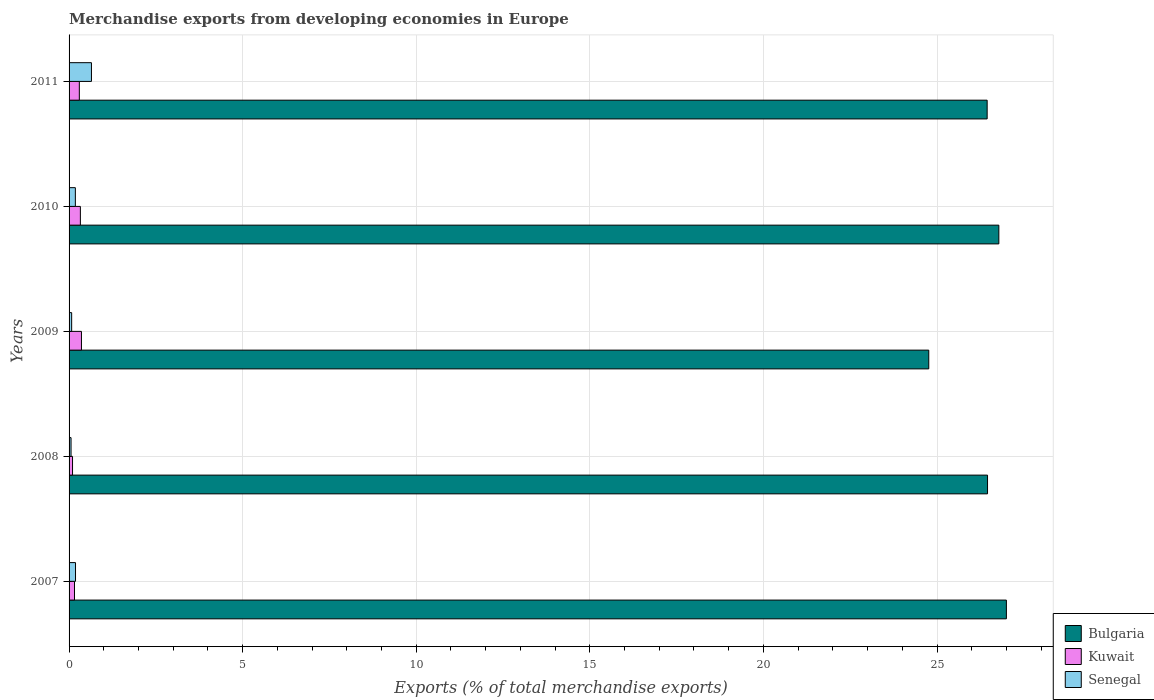How many different coloured bars are there?
Offer a terse response. 3. How many groups of bars are there?
Ensure brevity in your answer.  5. What is the label of the 2nd group of bars from the top?
Your response must be concise. 2010. In how many cases, is the number of bars for a given year not equal to the number of legend labels?
Give a very brief answer. 0. What is the percentage of total merchandise exports in Kuwait in 2008?
Your response must be concise. 0.1. Across all years, what is the maximum percentage of total merchandise exports in Senegal?
Offer a terse response. 0.64. Across all years, what is the minimum percentage of total merchandise exports in Kuwait?
Make the answer very short. 0.1. In which year was the percentage of total merchandise exports in Senegal maximum?
Your response must be concise. 2011. What is the total percentage of total merchandise exports in Bulgaria in the graph?
Provide a succinct answer. 131.44. What is the difference between the percentage of total merchandise exports in Senegal in 2008 and that in 2010?
Give a very brief answer. -0.12. What is the difference between the percentage of total merchandise exports in Senegal in 2010 and the percentage of total merchandise exports in Bulgaria in 2011?
Provide a short and direct response. -26.26. What is the average percentage of total merchandise exports in Bulgaria per year?
Your answer should be compact. 26.29. In the year 2007, what is the difference between the percentage of total merchandise exports in Bulgaria and percentage of total merchandise exports in Kuwait?
Offer a terse response. 26.84. In how many years, is the percentage of total merchandise exports in Bulgaria greater than 2 %?
Your answer should be compact. 5. What is the ratio of the percentage of total merchandise exports in Bulgaria in 2008 to that in 2009?
Your answer should be very brief. 1.07. What is the difference between the highest and the second highest percentage of total merchandise exports in Kuwait?
Provide a short and direct response. 0.03. What is the difference between the highest and the lowest percentage of total merchandise exports in Senegal?
Offer a terse response. 0.59. In how many years, is the percentage of total merchandise exports in Senegal greater than the average percentage of total merchandise exports in Senegal taken over all years?
Provide a short and direct response. 1. Is the sum of the percentage of total merchandise exports in Bulgaria in 2008 and 2011 greater than the maximum percentage of total merchandise exports in Kuwait across all years?
Make the answer very short. Yes. What does the 3rd bar from the top in 2010 represents?
Your answer should be very brief. Bulgaria. What does the 2nd bar from the bottom in 2008 represents?
Keep it short and to the point. Kuwait. Is it the case that in every year, the sum of the percentage of total merchandise exports in Bulgaria and percentage of total merchandise exports in Senegal is greater than the percentage of total merchandise exports in Kuwait?
Provide a succinct answer. Yes. Are all the bars in the graph horizontal?
Provide a short and direct response. Yes. How many years are there in the graph?
Provide a succinct answer. 5. Are the values on the major ticks of X-axis written in scientific E-notation?
Provide a succinct answer. No. Where does the legend appear in the graph?
Provide a short and direct response. Bottom right. How many legend labels are there?
Offer a very short reply. 3. How are the legend labels stacked?
Ensure brevity in your answer.  Vertical. What is the title of the graph?
Your response must be concise. Merchandise exports from developing economies in Europe. What is the label or title of the X-axis?
Your answer should be compact. Exports (% of total merchandise exports). What is the label or title of the Y-axis?
Offer a very short reply. Years. What is the Exports (% of total merchandise exports) of Bulgaria in 2007?
Provide a succinct answer. 27. What is the Exports (% of total merchandise exports) of Kuwait in 2007?
Make the answer very short. 0.16. What is the Exports (% of total merchandise exports) in Senegal in 2007?
Your response must be concise. 0.19. What is the Exports (% of total merchandise exports) in Bulgaria in 2008?
Your answer should be compact. 26.46. What is the Exports (% of total merchandise exports) in Kuwait in 2008?
Make the answer very short. 0.1. What is the Exports (% of total merchandise exports) in Senegal in 2008?
Offer a terse response. 0.06. What is the Exports (% of total merchandise exports) of Bulgaria in 2009?
Provide a short and direct response. 24.76. What is the Exports (% of total merchandise exports) of Kuwait in 2009?
Your response must be concise. 0.36. What is the Exports (% of total merchandise exports) in Senegal in 2009?
Provide a short and direct response. 0.07. What is the Exports (% of total merchandise exports) of Bulgaria in 2010?
Provide a short and direct response. 26.78. What is the Exports (% of total merchandise exports) of Kuwait in 2010?
Make the answer very short. 0.33. What is the Exports (% of total merchandise exports) in Senegal in 2010?
Keep it short and to the point. 0.18. What is the Exports (% of total merchandise exports) in Bulgaria in 2011?
Provide a succinct answer. 26.44. What is the Exports (% of total merchandise exports) in Kuwait in 2011?
Ensure brevity in your answer.  0.3. What is the Exports (% of total merchandise exports) of Senegal in 2011?
Provide a succinct answer. 0.64. Across all years, what is the maximum Exports (% of total merchandise exports) in Bulgaria?
Your response must be concise. 27. Across all years, what is the maximum Exports (% of total merchandise exports) of Kuwait?
Give a very brief answer. 0.36. Across all years, what is the maximum Exports (% of total merchandise exports) in Senegal?
Your response must be concise. 0.64. Across all years, what is the minimum Exports (% of total merchandise exports) of Bulgaria?
Provide a short and direct response. 24.76. Across all years, what is the minimum Exports (% of total merchandise exports) of Kuwait?
Your answer should be very brief. 0.1. Across all years, what is the minimum Exports (% of total merchandise exports) in Senegal?
Offer a very short reply. 0.06. What is the total Exports (% of total merchandise exports) in Bulgaria in the graph?
Offer a terse response. 131.44. What is the total Exports (% of total merchandise exports) in Kuwait in the graph?
Your answer should be very brief. 1.23. What is the total Exports (% of total merchandise exports) in Senegal in the graph?
Give a very brief answer. 1.14. What is the difference between the Exports (% of total merchandise exports) of Bulgaria in 2007 and that in 2008?
Keep it short and to the point. 0.54. What is the difference between the Exports (% of total merchandise exports) of Kuwait in 2007 and that in 2008?
Provide a succinct answer. 0.06. What is the difference between the Exports (% of total merchandise exports) in Senegal in 2007 and that in 2008?
Keep it short and to the point. 0.13. What is the difference between the Exports (% of total merchandise exports) of Bulgaria in 2007 and that in 2009?
Ensure brevity in your answer.  2.24. What is the difference between the Exports (% of total merchandise exports) in Kuwait in 2007 and that in 2009?
Provide a succinct answer. -0.2. What is the difference between the Exports (% of total merchandise exports) of Senegal in 2007 and that in 2009?
Give a very brief answer. 0.11. What is the difference between the Exports (% of total merchandise exports) of Bulgaria in 2007 and that in 2010?
Keep it short and to the point. 0.22. What is the difference between the Exports (% of total merchandise exports) of Kuwait in 2007 and that in 2010?
Your answer should be very brief. -0.17. What is the difference between the Exports (% of total merchandise exports) of Senegal in 2007 and that in 2010?
Make the answer very short. 0. What is the difference between the Exports (% of total merchandise exports) of Bulgaria in 2007 and that in 2011?
Your answer should be very brief. 0.55. What is the difference between the Exports (% of total merchandise exports) in Kuwait in 2007 and that in 2011?
Provide a short and direct response. -0.14. What is the difference between the Exports (% of total merchandise exports) in Senegal in 2007 and that in 2011?
Give a very brief answer. -0.46. What is the difference between the Exports (% of total merchandise exports) in Bulgaria in 2008 and that in 2009?
Offer a very short reply. 1.69. What is the difference between the Exports (% of total merchandise exports) of Kuwait in 2008 and that in 2009?
Your answer should be compact. -0.26. What is the difference between the Exports (% of total merchandise exports) in Senegal in 2008 and that in 2009?
Offer a terse response. -0.02. What is the difference between the Exports (% of total merchandise exports) in Bulgaria in 2008 and that in 2010?
Your response must be concise. -0.33. What is the difference between the Exports (% of total merchandise exports) in Kuwait in 2008 and that in 2010?
Provide a short and direct response. -0.23. What is the difference between the Exports (% of total merchandise exports) of Senegal in 2008 and that in 2010?
Your answer should be compact. -0.12. What is the difference between the Exports (% of total merchandise exports) of Bulgaria in 2008 and that in 2011?
Your answer should be very brief. 0.01. What is the difference between the Exports (% of total merchandise exports) in Kuwait in 2008 and that in 2011?
Give a very brief answer. -0.2. What is the difference between the Exports (% of total merchandise exports) in Senegal in 2008 and that in 2011?
Offer a terse response. -0.59. What is the difference between the Exports (% of total merchandise exports) of Bulgaria in 2009 and that in 2010?
Offer a terse response. -2.02. What is the difference between the Exports (% of total merchandise exports) in Kuwait in 2009 and that in 2010?
Provide a succinct answer. 0.03. What is the difference between the Exports (% of total merchandise exports) in Senegal in 2009 and that in 2010?
Make the answer very short. -0.11. What is the difference between the Exports (% of total merchandise exports) in Bulgaria in 2009 and that in 2011?
Provide a short and direct response. -1.68. What is the difference between the Exports (% of total merchandise exports) in Kuwait in 2009 and that in 2011?
Your response must be concise. 0.06. What is the difference between the Exports (% of total merchandise exports) of Senegal in 2009 and that in 2011?
Offer a terse response. -0.57. What is the difference between the Exports (% of total merchandise exports) of Bulgaria in 2010 and that in 2011?
Keep it short and to the point. 0.34. What is the difference between the Exports (% of total merchandise exports) of Kuwait in 2010 and that in 2011?
Provide a short and direct response. 0.03. What is the difference between the Exports (% of total merchandise exports) in Senegal in 2010 and that in 2011?
Provide a short and direct response. -0.46. What is the difference between the Exports (% of total merchandise exports) of Bulgaria in 2007 and the Exports (% of total merchandise exports) of Kuwait in 2008?
Your answer should be very brief. 26.9. What is the difference between the Exports (% of total merchandise exports) in Bulgaria in 2007 and the Exports (% of total merchandise exports) in Senegal in 2008?
Your answer should be compact. 26.94. What is the difference between the Exports (% of total merchandise exports) in Kuwait in 2007 and the Exports (% of total merchandise exports) in Senegal in 2008?
Make the answer very short. 0.1. What is the difference between the Exports (% of total merchandise exports) of Bulgaria in 2007 and the Exports (% of total merchandise exports) of Kuwait in 2009?
Give a very brief answer. 26.64. What is the difference between the Exports (% of total merchandise exports) in Bulgaria in 2007 and the Exports (% of total merchandise exports) in Senegal in 2009?
Offer a terse response. 26.92. What is the difference between the Exports (% of total merchandise exports) in Kuwait in 2007 and the Exports (% of total merchandise exports) in Senegal in 2009?
Your answer should be compact. 0.08. What is the difference between the Exports (% of total merchandise exports) of Bulgaria in 2007 and the Exports (% of total merchandise exports) of Kuwait in 2010?
Your answer should be very brief. 26.67. What is the difference between the Exports (% of total merchandise exports) of Bulgaria in 2007 and the Exports (% of total merchandise exports) of Senegal in 2010?
Keep it short and to the point. 26.82. What is the difference between the Exports (% of total merchandise exports) of Kuwait in 2007 and the Exports (% of total merchandise exports) of Senegal in 2010?
Your answer should be compact. -0.02. What is the difference between the Exports (% of total merchandise exports) of Bulgaria in 2007 and the Exports (% of total merchandise exports) of Kuwait in 2011?
Keep it short and to the point. 26.7. What is the difference between the Exports (% of total merchandise exports) of Bulgaria in 2007 and the Exports (% of total merchandise exports) of Senegal in 2011?
Offer a very short reply. 26.35. What is the difference between the Exports (% of total merchandise exports) in Kuwait in 2007 and the Exports (% of total merchandise exports) in Senegal in 2011?
Offer a terse response. -0.49. What is the difference between the Exports (% of total merchandise exports) of Bulgaria in 2008 and the Exports (% of total merchandise exports) of Kuwait in 2009?
Give a very brief answer. 26.1. What is the difference between the Exports (% of total merchandise exports) of Bulgaria in 2008 and the Exports (% of total merchandise exports) of Senegal in 2009?
Your answer should be very brief. 26.38. What is the difference between the Exports (% of total merchandise exports) of Kuwait in 2008 and the Exports (% of total merchandise exports) of Senegal in 2009?
Provide a succinct answer. 0.03. What is the difference between the Exports (% of total merchandise exports) in Bulgaria in 2008 and the Exports (% of total merchandise exports) in Kuwait in 2010?
Your answer should be very brief. 26.13. What is the difference between the Exports (% of total merchandise exports) in Bulgaria in 2008 and the Exports (% of total merchandise exports) in Senegal in 2010?
Offer a terse response. 26.27. What is the difference between the Exports (% of total merchandise exports) in Kuwait in 2008 and the Exports (% of total merchandise exports) in Senegal in 2010?
Offer a very short reply. -0.08. What is the difference between the Exports (% of total merchandise exports) in Bulgaria in 2008 and the Exports (% of total merchandise exports) in Kuwait in 2011?
Your answer should be very brief. 26.16. What is the difference between the Exports (% of total merchandise exports) of Bulgaria in 2008 and the Exports (% of total merchandise exports) of Senegal in 2011?
Provide a short and direct response. 25.81. What is the difference between the Exports (% of total merchandise exports) of Kuwait in 2008 and the Exports (% of total merchandise exports) of Senegal in 2011?
Provide a succinct answer. -0.55. What is the difference between the Exports (% of total merchandise exports) in Bulgaria in 2009 and the Exports (% of total merchandise exports) in Kuwait in 2010?
Ensure brevity in your answer.  24.44. What is the difference between the Exports (% of total merchandise exports) in Bulgaria in 2009 and the Exports (% of total merchandise exports) in Senegal in 2010?
Make the answer very short. 24.58. What is the difference between the Exports (% of total merchandise exports) in Kuwait in 2009 and the Exports (% of total merchandise exports) in Senegal in 2010?
Provide a short and direct response. 0.18. What is the difference between the Exports (% of total merchandise exports) of Bulgaria in 2009 and the Exports (% of total merchandise exports) of Kuwait in 2011?
Offer a very short reply. 24.47. What is the difference between the Exports (% of total merchandise exports) of Bulgaria in 2009 and the Exports (% of total merchandise exports) of Senegal in 2011?
Offer a very short reply. 24.12. What is the difference between the Exports (% of total merchandise exports) of Kuwait in 2009 and the Exports (% of total merchandise exports) of Senegal in 2011?
Offer a terse response. -0.29. What is the difference between the Exports (% of total merchandise exports) of Bulgaria in 2010 and the Exports (% of total merchandise exports) of Kuwait in 2011?
Provide a succinct answer. 26.49. What is the difference between the Exports (% of total merchandise exports) in Bulgaria in 2010 and the Exports (% of total merchandise exports) in Senegal in 2011?
Your answer should be compact. 26.14. What is the difference between the Exports (% of total merchandise exports) of Kuwait in 2010 and the Exports (% of total merchandise exports) of Senegal in 2011?
Provide a short and direct response. -0.32. What is the average Exports (% of total merchandise exports) in Bulgaria per year?
Give a very brief answer. 26.29. What is the average Exports (% of total merchandise exports) in Kuwait per year?
Your answer should be very brief. 0.25. What is the average Exports (% of total merchandise exports) in Senegal per year?
Your response must be concise. 0.23. In the year 2007, what is the difference between the Exports (% of total merchandise exports) in Bulgaria and Exports (% of total merchandise exports) in Kuwait?
Give a very brief answer. 26.84. In the year 2007, what is the difference between the Exports (% of total merchandise exports) of Bulgaria and Exports (% of total merchandise exports) of Senegal?
Give a very brief answer. 26.81. In the year 2007, what is the difference between the Exports (% of total merchandise exports) of Kuwait and Exports (% of total merchandise exports) of Senegal?
Your response must be concise. -0.03. In the year 2008, what is the difference between the Exports (% of total merchandise exports) of Bulgaria and Exports (% of total merchandise exports) of Kuwait?
Keep it short and to the point. 26.36. In the year 2008, what is the difference between the Exports (% of total merchandise exports) in Bulgaria and Exports (% of total merchandise exports) in Senegal?
Provide a succinct answer. 26.4. In the year 2008, what is the difference between the Exports (% of total merchandise exports) of Kuwait and Exports (% of total merchandise exports) of Senegal?
Ensure brevity in your answer.  0.04. In the year 2009, what is the difference between the Exports (% of total merchandise exports) of Bulgaria and Exports (% of total merchandise exports) of Kuwait?
Provide a succinct answer. 24.41. In the year 2009, what is the difference between the Exports (% of total merchandise exports) of Bulgaria and Exports (% of total merchandise exports) of Senegal?
Your response must be concise. 24.69. In the year 2009, what is the difference between the Exports (% of total merchandise exports) of Kuwait and Exports (% of total merchandise exports) of Senegal?
Provide a short and direct response. 0.28. In the year 2010, what is the difference between the Exports (% of total merchandise exports) of Bulgaria and Exports (% of total merchandise exports) of Kuwait?
Offer a very short reply. 26.46. In the year 2010, what is the difference between the Exports (% of total merchandise exports) of Bulgaria and Exports (% of total merchandise exports) of Senegal?
Your answer should be compact. 26.6. In the year 2010, what is the difference between the Exports (% of total merchandise exports) in Kuwait and Exports (% of total merchandise exports) in Senegal?
Make the answer very short. 0.14. In the year 2011, what is the difference between the Exports (% of total merchandise exports) in Bulgaria and Exports (% of total merchandise exports) in Kuwait?
Your answer should be compact. 26.15. In the year 2011, what is the difference between the Exports (% of total merchandise exports) of Bulgaria and Exports (% of total merchandise exports) of Senegal?
Offer a terse response. 25.8. In the year 2011, what is the difference between the Exports (% of total merchandise exports) of Kuwait and Exports (% of total merchandise exports) of Senegal?
Your answer should be very brief. -0.35. What is the ratio of the Exports (% of total merchandise exports) in Bulgaria in 2007 to that in 2008?
Your response must be concise. 1.02. What is the ratio of the Exports (% of total merchandise exports) of Kuwait in 2007 to that in 2008?
Your answer should be compact. 1.57. What is the ratio of the Exports (% of total merchandise exports) in Senegal in 2007 to that in 2008?
Your response must be concise. 3.25. What is the ratio of the Exports (% of total merchandise exports) in Bulgaria in 2007 to that in 2009?
Make the answer very short. 1.09. What is the ratio of the Exports (% of total merchandise exports) of Kuwait in 2007 to that in 2009?
Provide a succinct answer. 0.44. What is the ratio of the Exports (% of total merchandise exports) of Senegal in 2007 to that in 2009?
Keep it short and to the point. 2.49. What is the ratio of the Exports (% of total merchandise exports) in Kuwait in 2007 to that in 2010?
Give a very brief answer. 0.48. What is the ratio of the Exports (% of total merchandise exports) in Senegal in 2007 to that in 2010?
Offer a very short reply. 1.02. What is the ratio of the Exports (% of total merchandise exports) in Kuwait in 2007 to that in 2011?
Provide a succinct answer. 0.53. What is the ratio of the Exports (% of total merchandise exports) of Senegal in 2007 to that in 2011?
Offer a very short reply. 0.29. What is the ratio of the Exports (% of total merchandise exports) in Bulgaria in 2008 to that in 2009?
Offer a very short reply. 1.07. What is the ratio of the Exports (% of total merchandise exports) of Kuwait in 2008 to that in 2009?
Offer a terse response. 0.28. What is the ratio of the Exports (% of total merchandise exports) in Senegal in 2008 to that in 2009?
Your answer should be very brief. 0.77. What is the ratio of the Exports (% of total merchandise exports) of Kuwait in 2008 to that in 2010?
Offer a very short reply. 0.31. What is the ratio of the Exports (% of total merchandise exports) in Senegal in 2008 to that in 2010?
Offer a very short reply. 0.32. What is the ratio of the Exports (% of total merchandise exports) in Bulgaria in 2008 to that in 2011?
Provide a short and direct response. 1. What is the ratio of the Exports (% of total merchandise exports) of Kuwait in 2008 to that in 2011?
Your answer should be compact. 0.34. What is the ratio of the Exports (% of total merchandise exports) in Senegal in 2008 to that in 2011?
Your response must be concise. 0.09. What is the ratio of the Exports (% of total merchandise exports) of Bulgaria in 2009 to that in 2010?
Keep it short and to the point. 0.92. What is the ratio of the Exports (% of total merchandise exports) in Kuwait in 2009 to that in 2010?
Ensure brevity in your answer.  1.1. What is the ratio of the Exports (% of total merchandise exports) in Senegal in 2009 to that in 2010?
Your answer should be very brief. 0.41. What is the ratio of the Exports (% of total merchandise exports) in Bulgaria in 2009 to that in 2011?
Provide a succinct answer. 0.94. What is the ratio of the Exports (% of total merchandise exports) of Kuwait in 2009 to that in 2011?
Ensure brevity in your answer.  1.21. What is the ratio of the Exports (% of total merchandise exports) in Senegal in 2009 to that in 2011?
Your answer should be very brief. 0.12. What is the ratio of the Exports (% of total merchandise exports) in Bulgaria in 2010 to that in 2011?
Offer a very short reply. 1.01. What is the ratio of the Exports (% of total merchandise exports) of Kuwait in 2010 to that in 2011?
Make the answer very short. 1.1. What is the ratio of the Exports (% of total merchandise exports) of Senegal in 2010 to that in 2011?
Your answer should be very brief. 0.28. What is the difference between the highest and the second highest Exports (% of total merchandise exports) of Bulgaria?
Make the answer very short. 0.22. What is the difference between the highest and the second highest Exports (% of total merchandise exports) of Kuwait?
Make the answer very short. 0.03. What is the difference between the highest and the second highest Exports (% of total merchandise exports) in Senegal?
Make the answer very short. 0.46. What is the difference between the highest and the lowest Exports (% of total merchandise exports) of Bulgaria?
Make the answer very short. 2.24. What is the difference between the highest and the lowest Exports (% of total merchandise exports) in Kuwait?
Your answer should be compact. 0.26. What is the difference between the highest and the lowest Exports (% of total merchandise exports) in Senegal?
Keep it short and to the point. 0.59. 